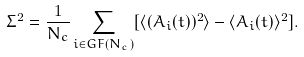<formula> <loc_0><loc_0><loc_500><loc_500>\Sigma ^ { 2 } = \frac { 1 } { N _ { c } } \sum _ { i \in G F ( N _ { c } ) } [ \langle ( A _ { i } ( t ) ) ^ { 2 } \rangle - \langle A _ { i } ( t ) \rangle ^ { 2 } ] .</formula> 